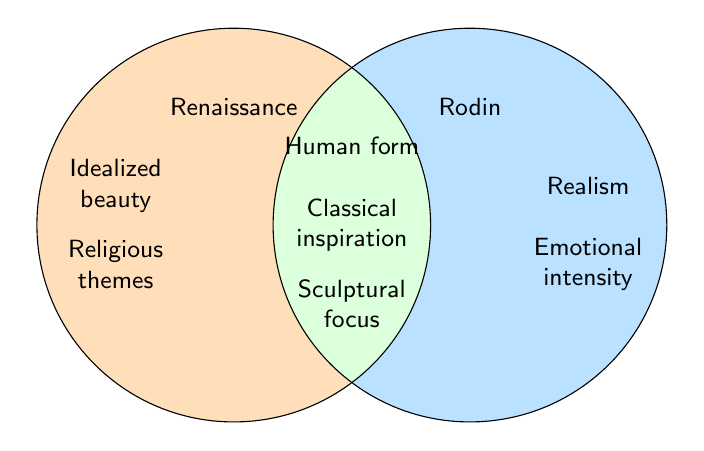What are the main themes shared by both the Renaissance and Rodin? The middle section of the Venn Diagram represents themes shared by both. The shared themes are Human form, Classical inspiration, and Sculptural focus.
Answer: Human form, Classical inspiration, Sculptural focus What theme is unique to Rodin but not present in Renaissance? The themes unique to Rodin are in the right circle that is not intersecting with the left circle. The unique themes are Realism and Emotional intensity.
Answer: Realism, Emotional intensity Which themes are exclusive to the Renaissance? The themes exclusive to the Renaissance are in the left circle that is not intersecting with the right circle. The unique themes are Idealized beauty and Religious themes.
Answer: Idealized beauty, Religious themes How many themes are there in total? Count all themes in the Venn Diagram, including unique and shared themes. There are 5 themes in Renaissance, 5 in Rodin, and 3 are shared (which are repeated in both groups). Total distinct themes is 5 + 5 - 3 = 7.
Answer: 7 Which theme appears in both circles but relates to innovation techniques? Identify the shared themes and check if any of them relates to innovation techniques. None of the shared themes (Human form, Classical inspiration, and Sculptural focus) relate to innovation techniques directly.
Answer: None 